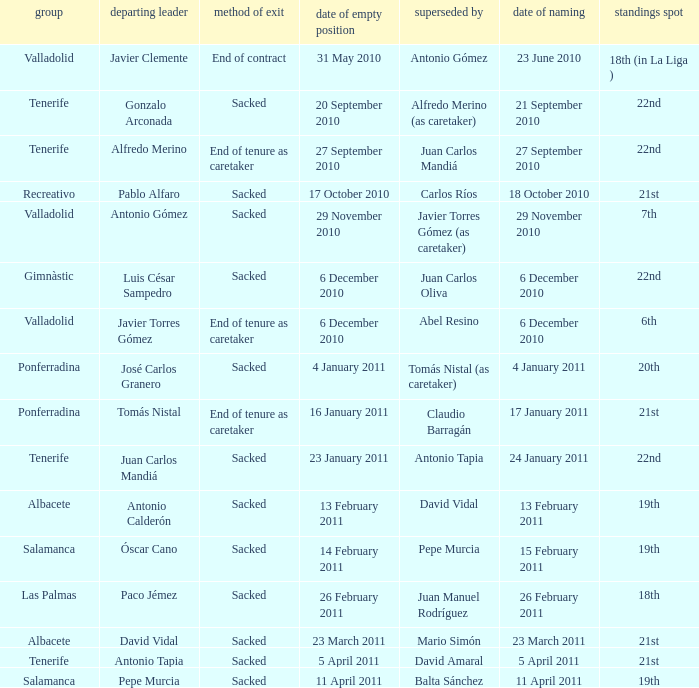What was the position of appointment date 17 january 2011 21st. Would you be able to parse every entry in this table? {'header': ['group', 'departing leader', 'method of exit', 'date of empty position', 'superseded by', 'date of naming', 'standings spot'], 'rows': [['Valladolid', 'Javier Clemente', 'End of contract', '31 May 2010', 'Antonio Gómez', '23 June 2010', '18th (in La Liga )'], ['Tenerife', 'Gonzalo Arconada', 'Sacked', '20 September 2010', 'Alfredo Merino (as caretaker)', '21 September 2010', '22nd'], ['Tenerife', 'Alfredo Merino', 'End of tenure as caretaker', '27 September 2010', 'Juan Carlos Mandiá', '27 September 2010', '22nd'], ['Recreativo', 'Pablo Alfaro', 'Sacked', '17 October 2010', 'Carlos Ríos', '18 October 2010', '21st'], ['Valladolid', 'Antonio Gómez', 'Sacked', '29 November 2010', 'Javier Torres Gómez (as caretaker)', '29 November 2010', '7th'], ['Gimnàstic', 'Luis César Sampedro', 'Sacked', '6 December 2010', 'Juan Carlos Oliva', '6 December 2010', '22nd'], ['Valladolid', 'Javier Torres Gómez', 'End of tenure as caretaker', '6 December 2010', 'Abel Resino', '6 December 2010', '6th'], ['Ponferradina', 'José Carlos Granero', 'Sacked', '4 January 2011', 'Tomás Nistal (as caretaker)', '4 January 2011', '20th'], ['Ponferradina', 'Tomás Nistal', 'End of tenure as caretaker', '16 January 2011', 'Claudio Barragán', '17 January 2011', '21st'], ['Tenerife', 'Juan Carlos Mandiá', 'Sacked', '23 January 2011', 'Antonio Tapia', '24 January 2011', '22nd'], ['Albacete', 'Antonio Calderón', 'Sacked', '13 February 2011', 'David Vidal', '13 February 2011', '19th'], ['Salamanca', 'Óscar Cano', 'Sacked', '14 February 2011', 'Pepe Murcia', '15 February 2011', '19th'], ['Las Palmas', 'Paco Jémez', 'Sacked', '26 February 2011', 'Juan Manuel Rodríguez', '26 February 2011', '18th'], ['Albacete', 'David Vidal', 'Sacked', '23 March 2011', 'Mario Simón', '23 March 2011', '21st'], ['Tenerife', 'Antonio Tapia', 'Sacked', '5 April 2011', 'David Amaral', '5 April 2011', '21st'], ['Salamanca', 'Pepe Murcia', 'Sacked', '11 April 2011', 'Balta Sánchez', '11 April 2011', '19th']]} 